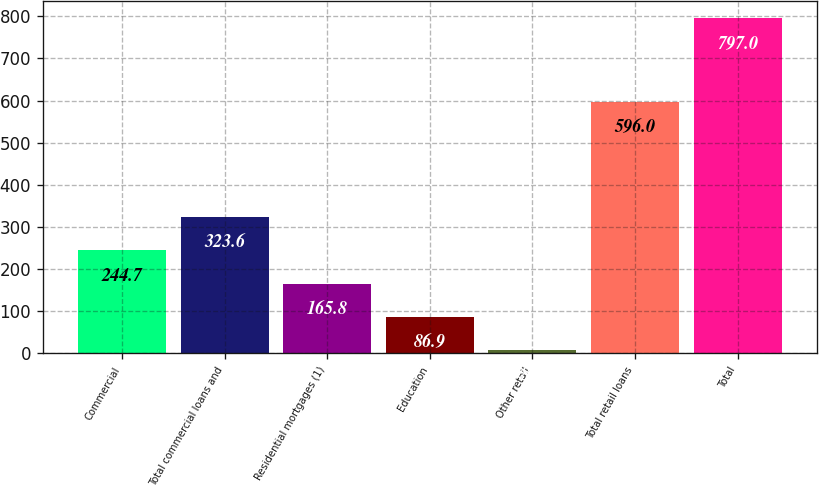Convert chart to OTSL. <chart><loc_0><loc_0><loc_500><loc_500><bar_chart><fcel>Commercial<fcel>Total commercial loans and<fcel>Residential mortgages (1)<fcel>Education<fcel>Other retail<fcel>Total retail loans<fcel>Total<nl><fcel>244.7<fcel>323.6<fcel>165.8<fcel>86.9<fcel>8<fcel>596<fcel>797<nl></chart> 